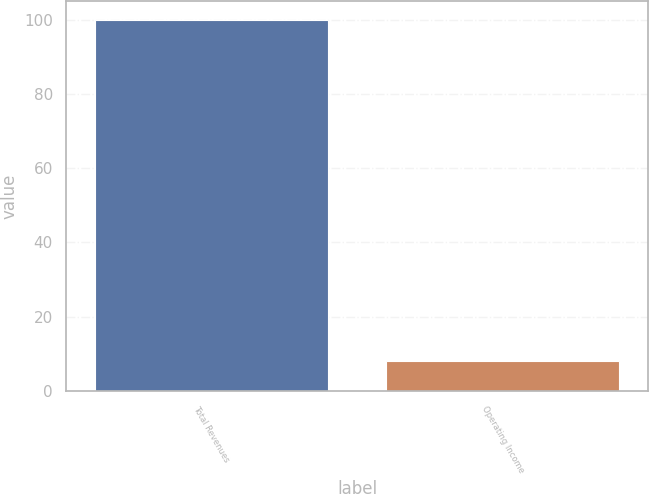<chart> <loc_0><loc_0><loc_500><loc_500><bar_chart><fcel>Total Revenues<fcel>Operating Income<nl><fcel>100<fcel>8<nl></chart> 